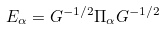Convert formula to latex. <formula><loc_0><loc_0><loc_500><loc_500>E _ { \alpha } = G ^ { - 1 / 2 } \Pi _ { \alpha } G ^ { - 1 / 2 }</formula> 